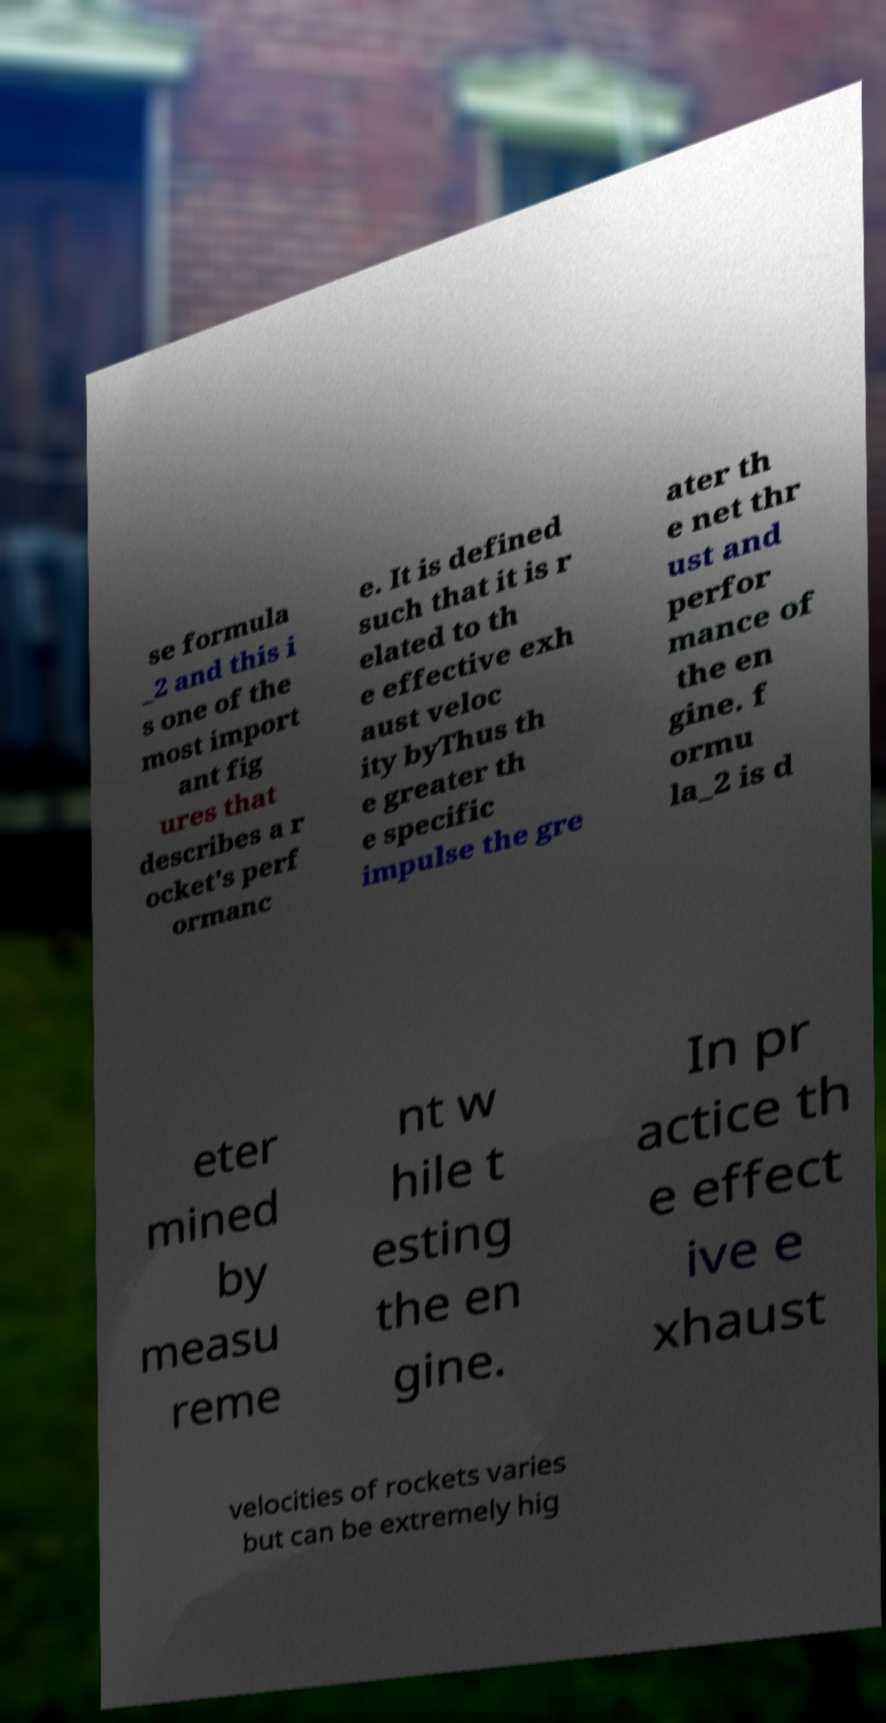What messages or text are displayed in this image? I need them in a readable, typed format. se formula _2 and this i s one of the most import ant fig ures that describes a r ocket's perf ormanc e. It is defined such that it is r elated to th e effective exh aust veloc ity byThus th e greater th e specific impulse the gre ater th e net thr ust and perfor mance of the en gine. f ormu la_2 is d eter mined by measu reme nt w hile t esting the en gine. In pr actice th e effect ive e xhaust velocities of rockets varies but can be extremely hig 